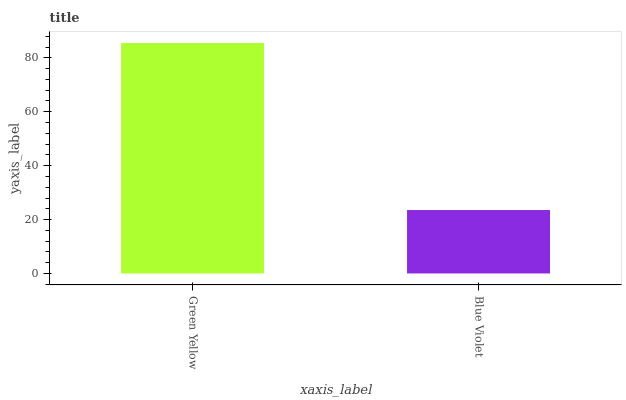Is Blue Violet the minimum?
Answer yes or no. Yes. Is Green Yellow the maximum?
Answer yes or no. Yes. Is Blue Violet the maximum?
Answer yes or no. No. Is Green Yellow greater than Blue Violet?
Answer yes or no. Yes. Is Blue Violet less than Green Yellow?
Answer yes or no. Yes. Is Blue Violet greater than Green Yellow?
Answer yes or no. No. Is Green Yellow less than Blue Violet?
Answer yes or no. No. Is Green Yellow the high median?
Answer yes or no. Yes. Is Blue Violet the low median?
Answer yes or no. Yes. Is Blue Violet the high median?
Answer yes or no. No. Is Green Yellow the low median?
Answer yes or no. No. 